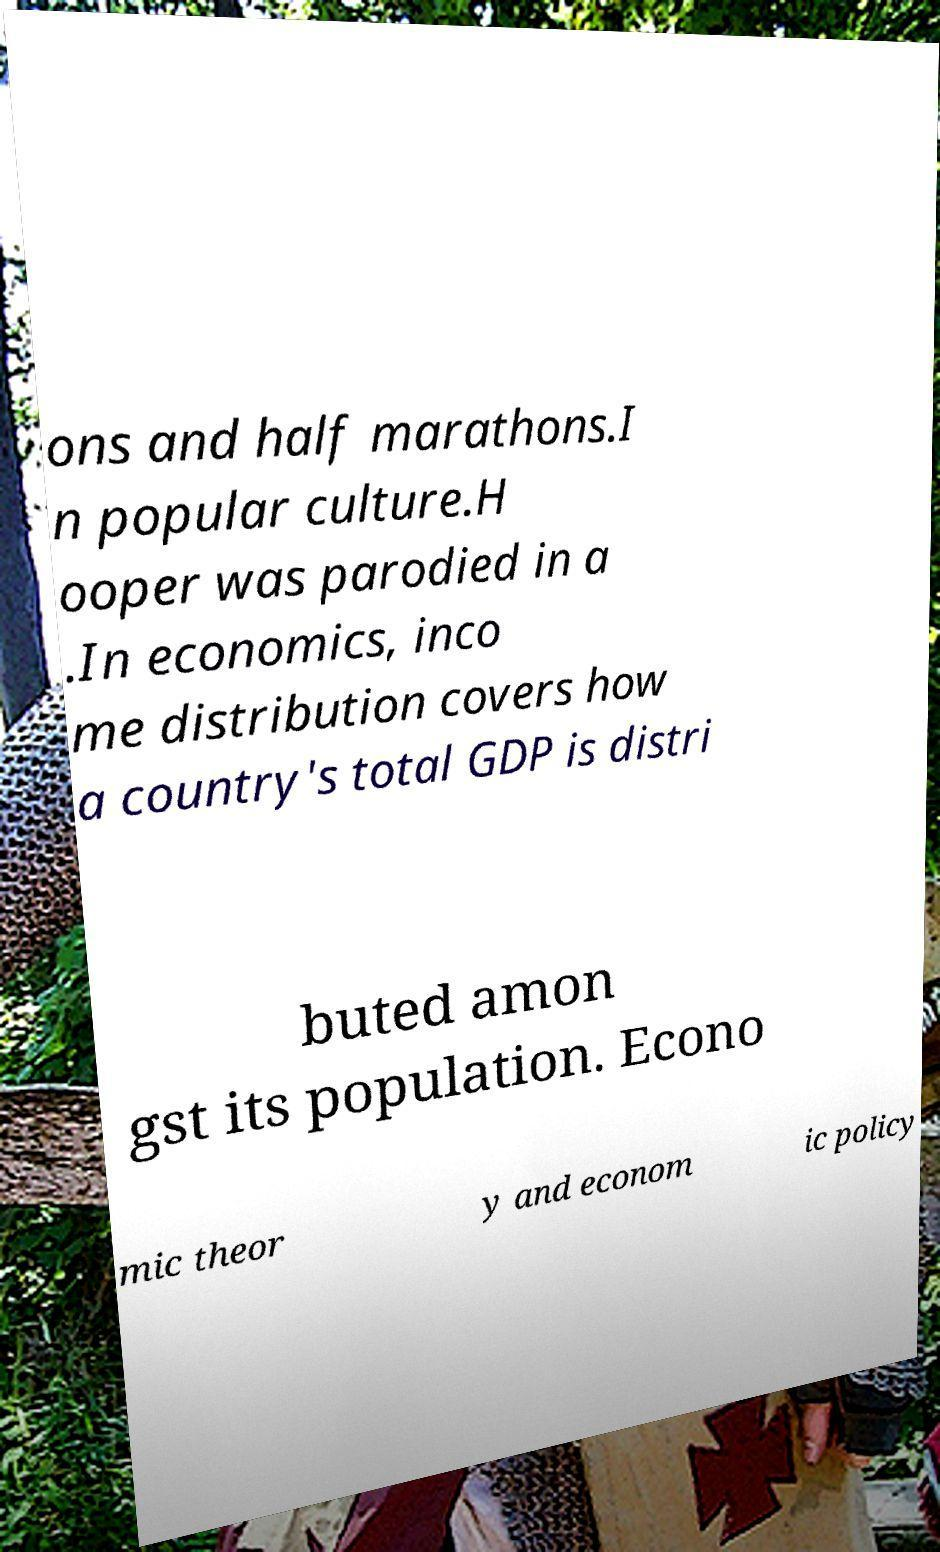Could you assist in decoding the text presented in this image and type it out clearly? ons and half marathons.I n popular culture.H ooper was parodied in a .In economics, inco me distribution covers how a country's total GDP is distri buted amon gst its population. Econo mic theor y and econom ic policy 